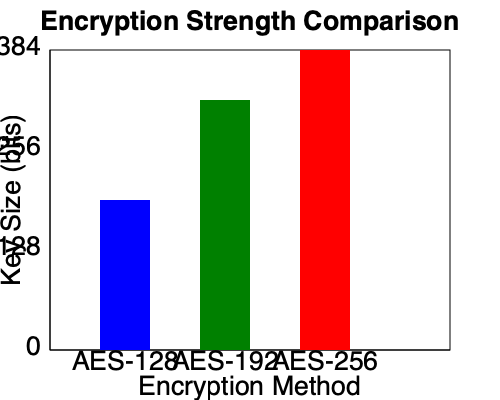Based on the bar graph comparing different encryption methods, which AES encryption algorithm provides the highest level of security for our financial institution's network? To determine which AES encryption algorithm provides the highest level of security, we need to analyze the key sizes represented in the bar graph:

1. Identify the encryption methods: The graph shows three AES encryption methods - AES-128, AES-192, and AES-256.

2. Compare key sizes:
   - AES-128: The blue bar reaches approximately 128 bits on the y-axis.
   - AES-192: The green bar reaches approximately 256 bits on the y-axis.
   - AES-256: The red bar reaches the top of the graph at 384 bits on the y-axis.

3. Interpret the data: In encryption, a larger key size generally indicates stronger security. This is because larger key sizes make it exponentially more difficult for attackers to break the encryption through brute-force methods.

4. Conclusion: AES-256 has the largest key size of 256 bits (represented by the tallest bar in the graph), making it the most secure option among the three.

Therefore, AES-256 provides the highest level of security for our financial institution's network based on the information presented in the graph.
Answer: AES-256 